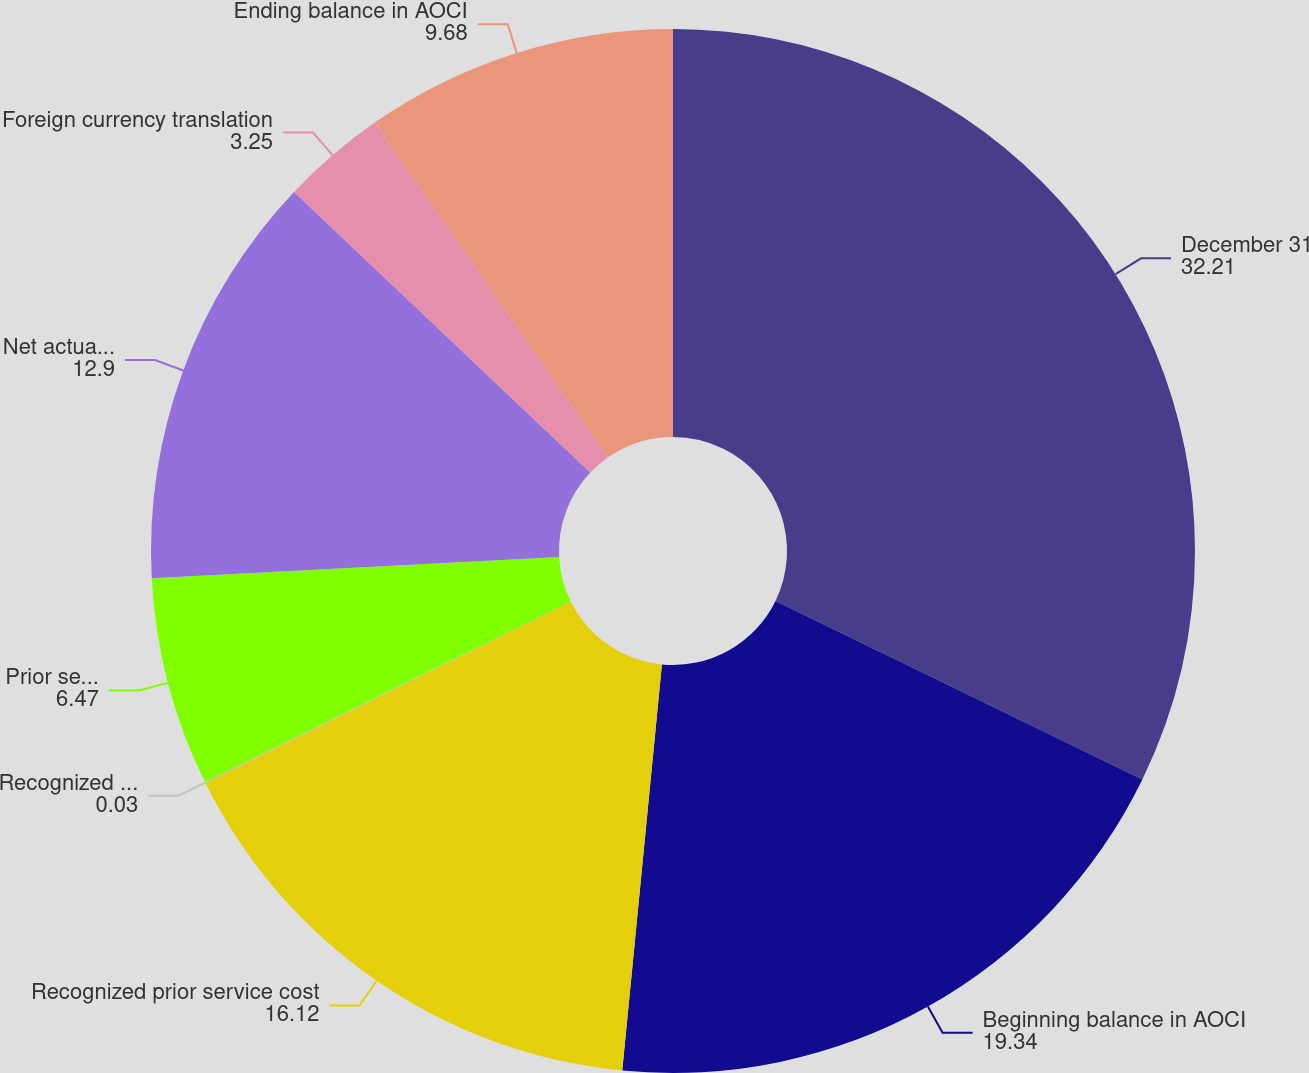Convert chart. <chart><loc_0><loc_0><loc_500><loc_500><pie_chart><fcel>December 31<fcel>Beginning balance in AOCI<fcel>Recognized prior service cost<fcel>Recognized net actuarial loss<fcel>Prior service credit (cost)<fcel>Net actuarial (loss) gain<fcel>Foreign currency translation<fcel>Ending balance in AOCI<nl><fcel>32.21%<fcel>19.34%<fcel>16.12%<fcel>0.03%<fcel>6.47%<fcel>12.9%<fcel>3.25%<fcel>9.68%<nl></chart> 